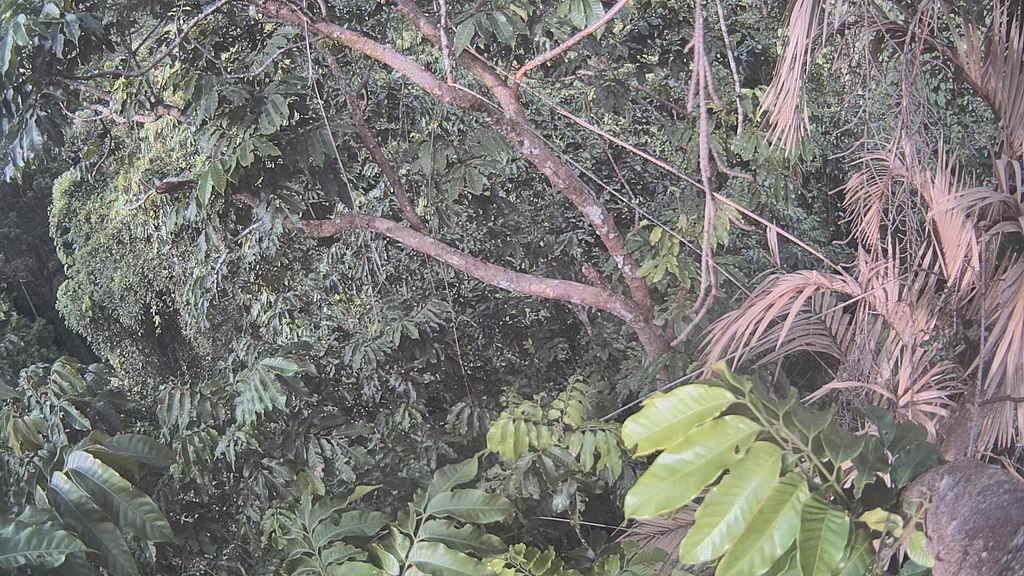What types of vegetation can be seen in the image? The image contains different types of trees. Can you describe a specific detail about the trees on the right side of the image? There are dried palm tree leaves on the right side of the image. What type of mark can be seen on the tree in the image? There is no mark visible on any of the trees in the image. Is anyone wearing a mask in the image? There are no people present in the image, so no one is wearing a mask. 